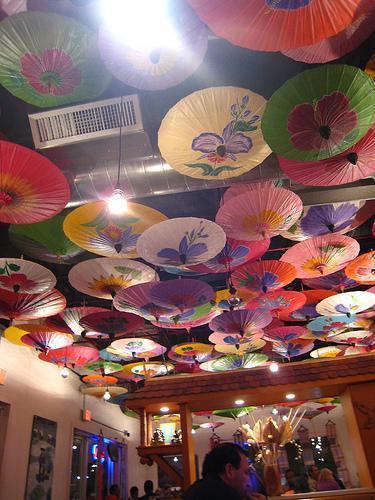How many green unbrella's are hanging from the ceiling?
Give a very brief answer. 6. 